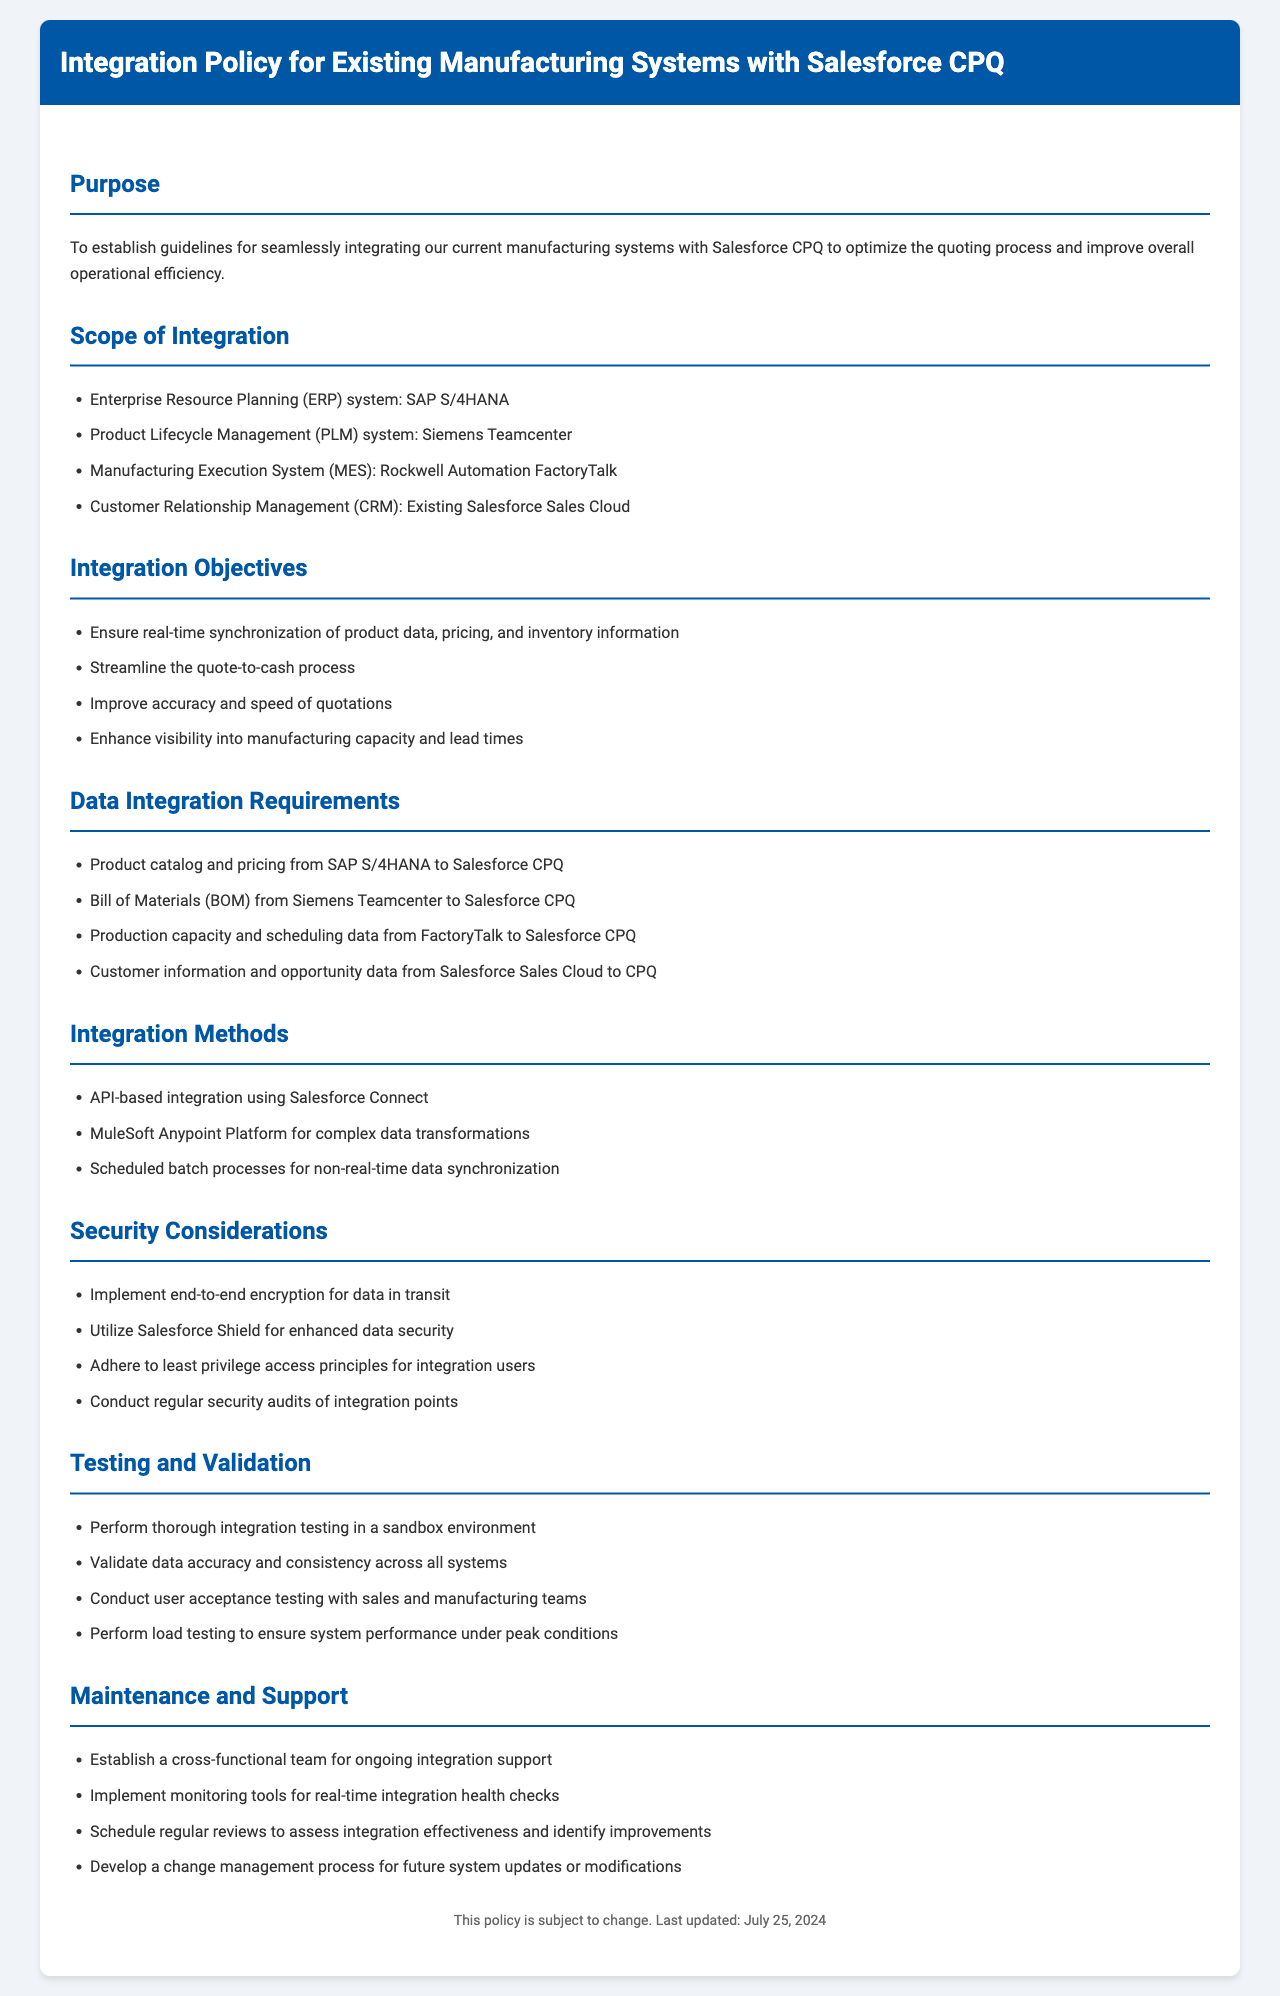What is the purpose of the policy? The purpose is to establish guidelines for integrating current manufacturing systems with Salesforce CPQ to optimize quoting and improve operational efficiency.
Answer: To establish guidelines for seamlessly integrating our current manufacturing systems with Salesforce CPQ to optimize the quoting process and improve overall operational efficiency Which ERP system is mentioned for integration? The policy lists the systems included in the integration scope, specifically identifying the ERP system.
Answer: SAP S/4HANA Name one integration method described in the document. The document specifies various integration methods available for connecting systems, one of which is highlighted as an API-based option.
Answer: API-based integration using Salesforce Connect What is one integration objective stated? The integration objectives in the document outline the desired outcomes of the integration process, requiring identification of one such objective.
Answer: Ensure real-time synchronization of product data, pricing, and inventory information What kind of testing is required for validation? The document includes a section dedicated to testing and validation, detailing the types of testing that should be performed to ensure integration success.
Answer: Integration testing in a sandbox environment How often should reviews of integration effectiveness be scheduled? The maintenance and support section implies a routine review process, which hints at frequency but doesn't provide a direct number, only mentioning scheduled intervals.
Answer: Regularly What security measure is suggested for data? The security considerations outline various measures to secure data during integration, including specific recommendations.
Answer: End-to-end encryption for data in transit 